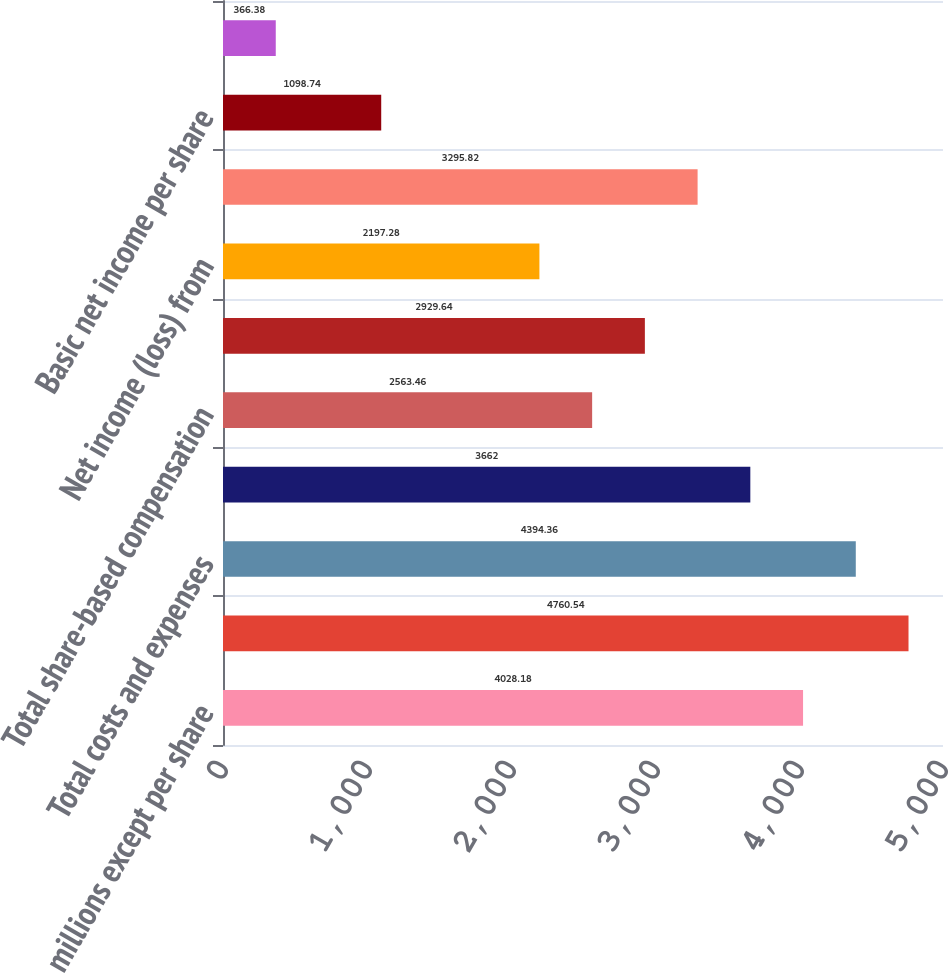Convert chart to OTSL. <chart><loc_0><loc_0><loc_500><loc_500><bar_chart><fcel>(In millions except per share<fcel>Total net revenue<fcel>Total costs and expenses<fcel>Operating income from<fcel>Total share-based compensation<fcel>Net income from continuing<fcel>Net income (loss) from<fcel>Net income<fcel>Basic net income per share<fcel>Basic net income (loss) per<nl><fcel>4028.18<fcel>4760.54<fcel>4394.36<fcel>3662<fcel>2563.46<fcel>2929.64<fcel>2197.28<fcel>3295.82<fcel>1098.74<fcel>366.38<nl></chart> 